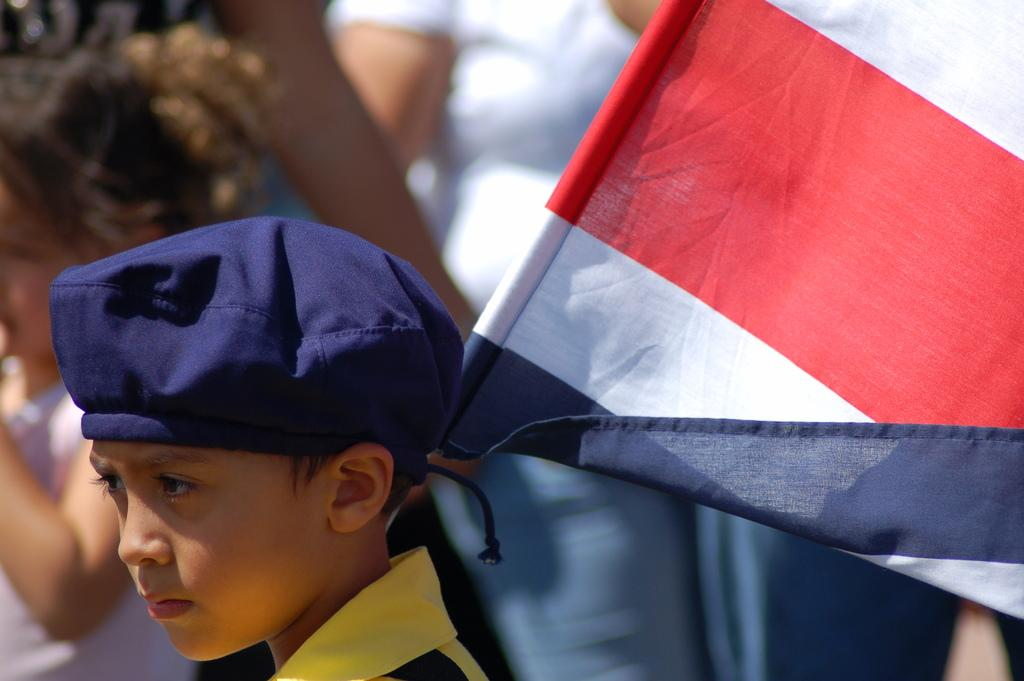Who is the main subject in the image? There is a boy in the image. What is the boy wearing on his upper body? The boy is wearing a t-shirt. What is the boy wearing on his head? The boy is wearing a cap on his head. What is the boy holding in the image? The boy is holding a flag. Can you describe the background of the image? There are people in the background of the image. What type of engine can be seen in the image? There is no engine present in the image. How does the knife help the boy in the image? There is no knife present in the image, so it cannot help the boy. 